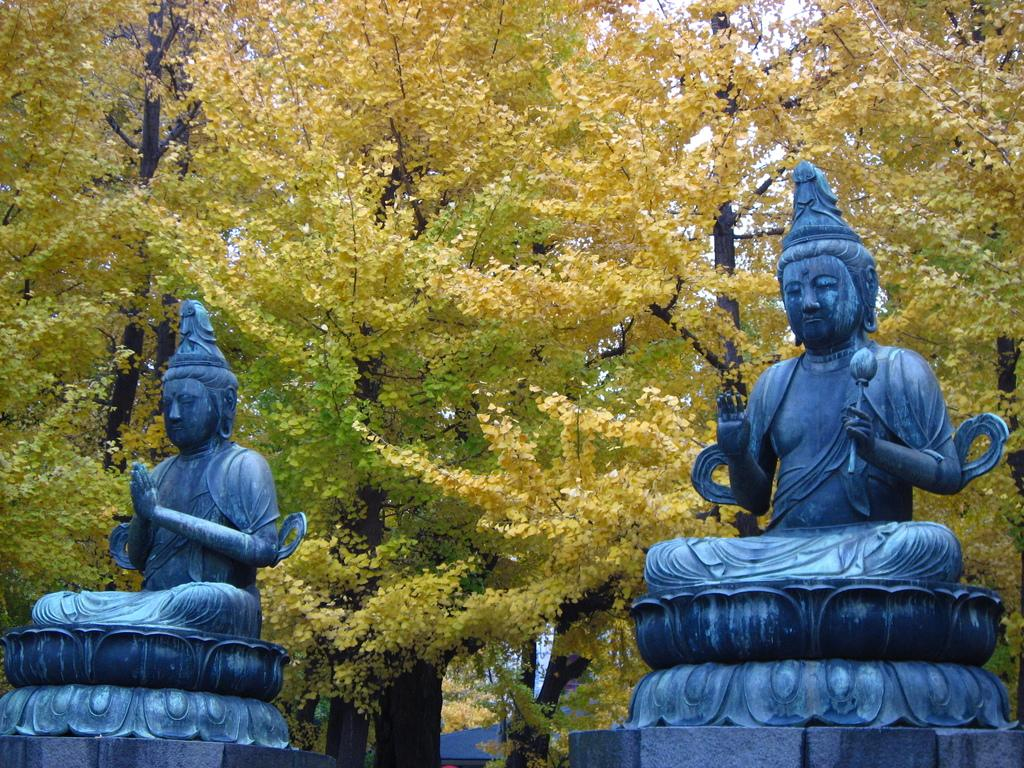What type of objects are depicted as statues in the image? There are statues of persons in the image. What natural elements can be seen in the image? There are many trees in the image. Where is the house located in the image? The house is at the bottom of the image. How many stars can be seen in the image? There are no stars visible in the image; it features statues, trees, and a house. What type of sail is present in the image? There is no sail present in the image. 